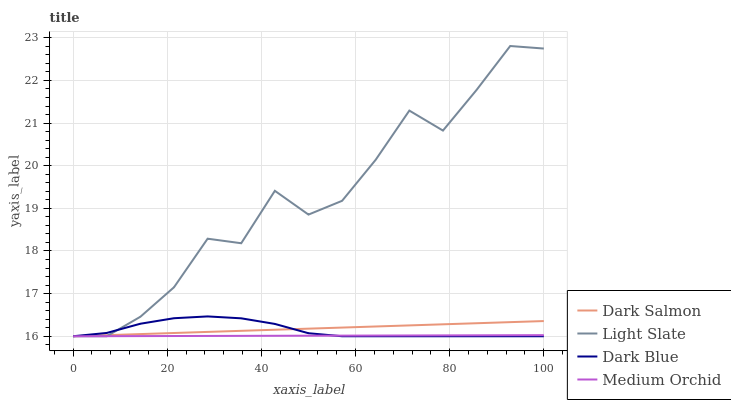Does Medium Orchid have the minimum area under the curve?
Answer yes or no. Yes. Does Light Slate have the maximum area under the curve?
Answer yes or no. Yes. Does Dark Blue have the minimum area under the curve?
Answer yes or no. No. Does Dark Blue have the maximum area under the curve?
Answer yes or no. No. Is Medium Orchid the smoothest?
Answer yes or no. Yes. Is Light Slate the roughest?
Answer yes or no. Yes. Is Dark Blue the smoothest?
Answer yes or no. No. Is Dark Blue the roughest?
Answer yes or no. No. Does Light Slate have the highest value?
Answer yes or no. Yes. Does Dark Blue have the highest value?
Answer yes or no. No. Does Medium Orchid intersect Light Slate?
Answer yes or no. Yes. Is Medium Orchid less than Light Slate?
Answer yes or no. No. Is Medium Orchid greater than Light Slate?
Answer yes or no. No. 